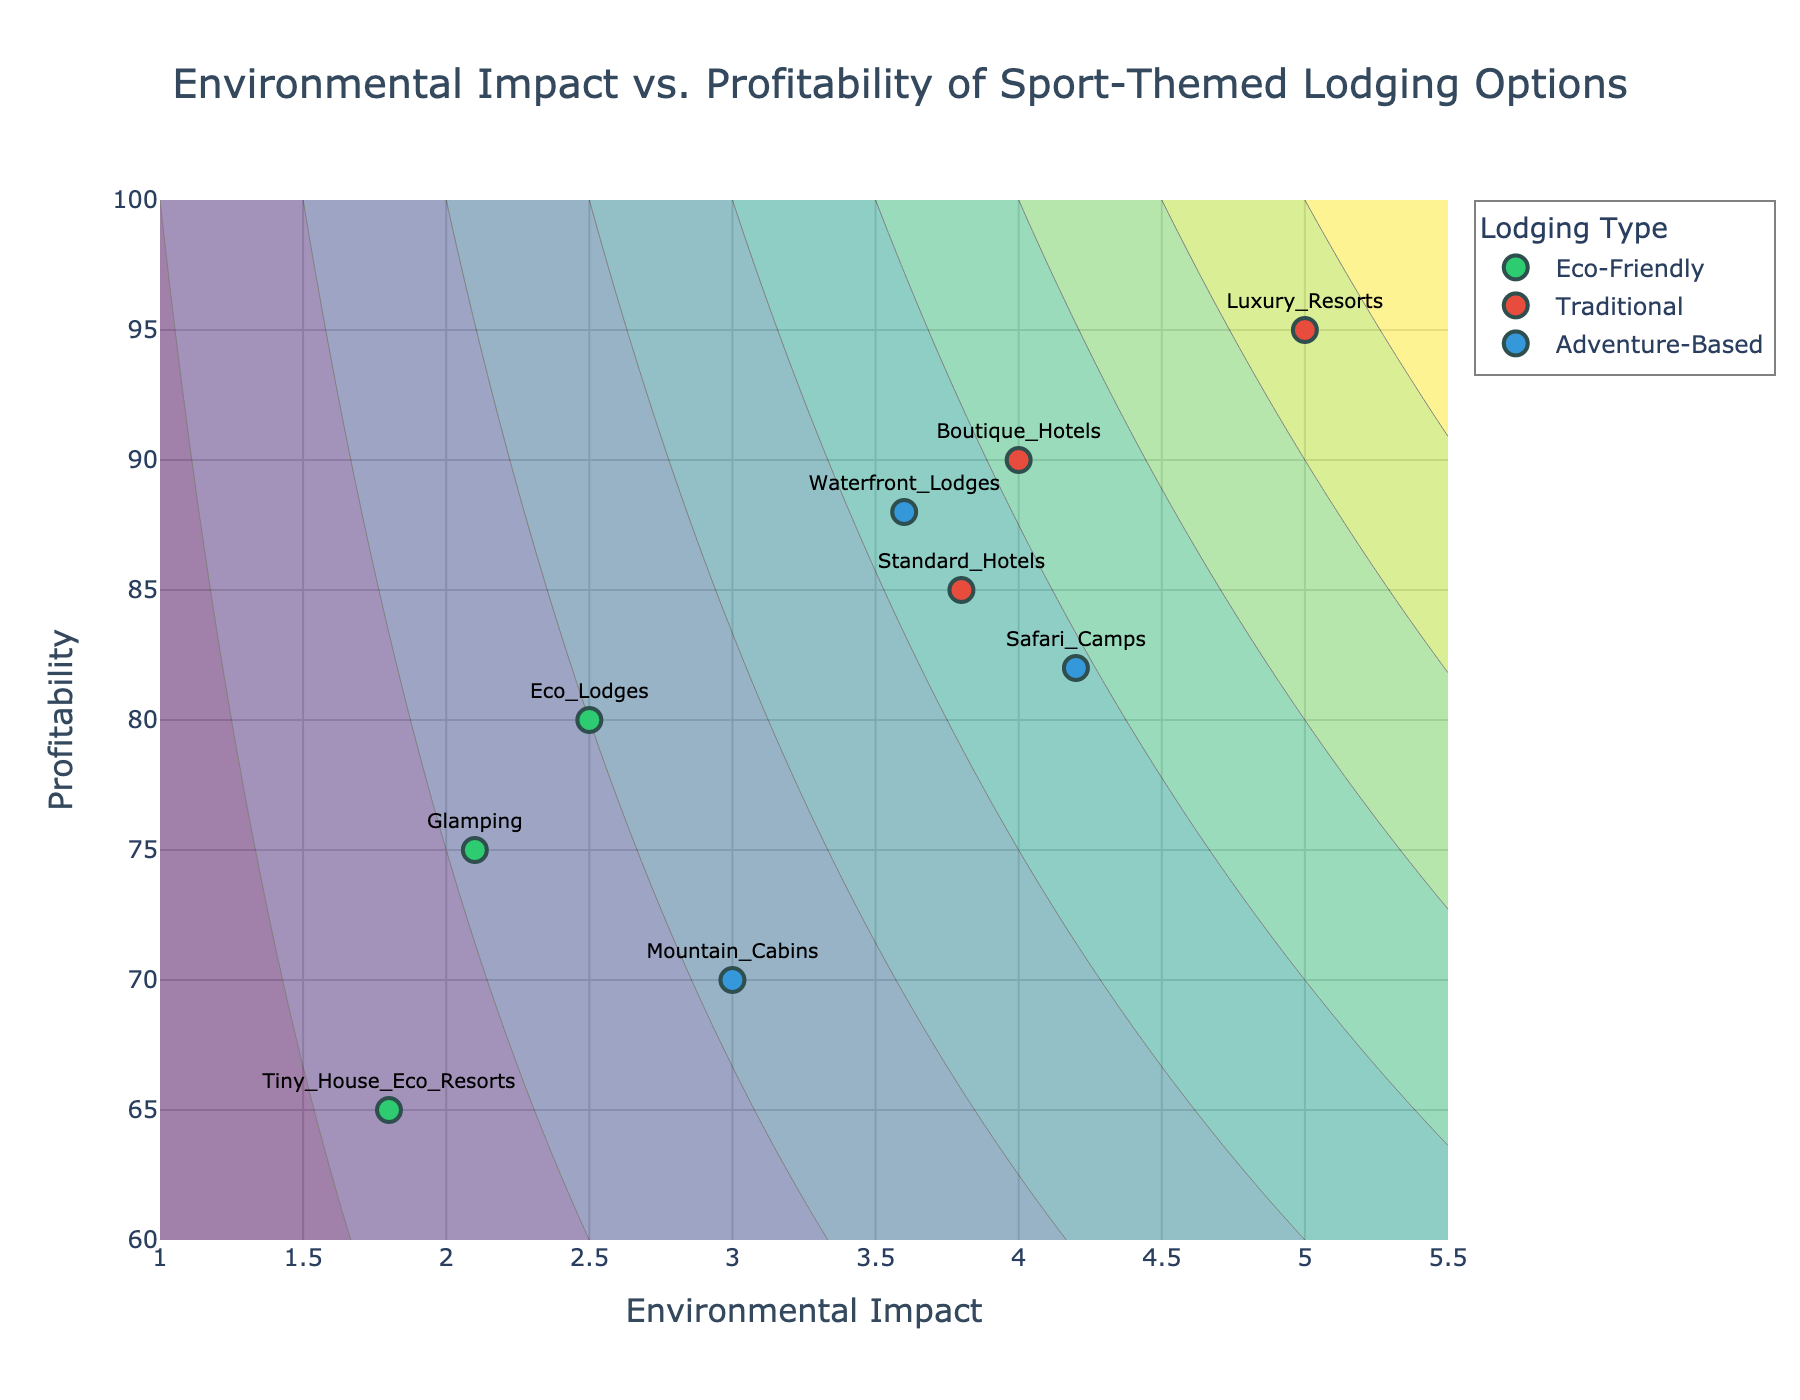What's the title of the figure? The title of the figure is located at the top of the plot, generally in a larger and bolded font. Here, it reads "Environmental Impact vs. Profitability of Sport-Themed Lodging Options."
Answer: Environmental Impact vs. Profitability of Sport-Themed Lodging Options What is the range of the x-axis? By looking at the x-axis, the numbers along the horizontal line indicate the range, starting from 1 and ending at 5.5.
Answer: 1 to 5.5 How many lodging options are categorized under "Traditional"? Find and count the markers labeled with the "Traditional" lodging types which are Boutique_Hotels, Luxury_Resorts, and Standard_Hotels.
Answer: 3 Which lodging option has the highest environmental impact? Among the labeled options, Luxury_Resorts has the highest environmental impact value given as 5.0.
Answer: Luxury_Resorts What is the profitability of Eco Lodges? Locate the text label "Eco_Lodges" on the plot and find its corresponding value on the y-axis. The value is 80.
Answer: 80 Which "Adventure-Based" lodging option has the highest profitability? Look at all "Adventure-Based" options' profitability and compare them. Waterfront_Lodges has the highest profitability at 88.
Answer: Waterfront_Lodges What is the difference in environmental impact between Glamping and Safari Camps? Find the environmental impact values for Glamping (2.1) and Safari Camps (4.2) and calculate the difference: 4.2 - 2.1 = 2.1.
Answer: 2.1 Between Tiny_House_Eco_Resorts and Standard_Hotels, which is more profitable and by how much? Compare their profitability values: Standard_Hotels is 85 and Tiny_House_Eco_Resorts is 65. The difference is 85 - 65 = 20, and Standard_Hotels is more profitable.
Answer: Standard_Hotels by 20 What is the average profitability of all Eco-Friendly lodging options? The three Eco-Friendly options have profitability values of: Glamping (75), Tiny_House_Eco_Resorts (65), and Eco_Lodges (80). Their sum is 75 + 65 + 80 = 220. There are 3 options, so 220 / 3 ≈ 73.33.
Answer: 73.33 What can be inferred about the relationship between environmental impact and profitability from the contour lines? The contour lines show areas of constant values derived from an X*Y/10 relationship. The general trend from the plotted data suggests that higher environmental impact may lead to higher profitability, especially noticeable in the "Traditional" category.
Answer: Higher environmental impact tends to higher profitability 